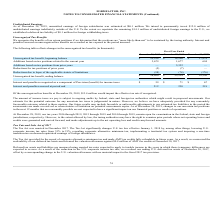According to Formfactor's financial document, What is the unrecognized tax benefit, ending balance in 2019? According to the financial document, $28,800 (in thousands). The relevant text states: "Unrecognized tax benefit, ending balance $ 28,800 $ 25,224 $ 18,296..." Also, What were the Unrecognized tax benefit, beginning balance in 2019, 2018 and 2017 respectively? The document contains multiple relevant values: 25,224, 18,296, 17,978 (in thousands). From the document: "ognized tax benefit, beginning balance $ 25,224 $ 18,296 $ 17,978 Unrecognized tax benefit, beginning balance $ 25,224 $ 18,296 $ 17,978 ax benefit, b..." Also, Which tax years are open for examination in the federal, state and foreign jurisdictions respectively? The document contains multiple relevant values: 2016 through 2019, 2015 through 2019, 2014 through 2019. From the document: "At December 28, 2019, our tax years 2016 through 2019, 2015 through 2019 and 2014 through 2019, remain open for examination in the federal, state and ..." Also, can you calculate: What is the change in the Unrecognized tax benefit, beginning balance from 2018 to 2019? Based on the calculation: 25,224 - 18,296, the result is 6928 (in thousands). This is based on the information: "ognized tax benefit, beginning balance $ 25,224 $ 18,296 $ 17,978 Unrecognized tax benefit, beginning balance $ 25,224 $ 18,296 $ 17,978..." The key data points involved are: 18,296, 25,224. Also, can you calculate: What is the average Additions based on tax positions related to the current year from 2017-2019? To answer this question, I need to perform calculations using the financial data. The calculation is: (3,679 + 1,677 + 694) / 3, which equals 2016.67 (in thousands). This is based on the information: "positions related to the current year 3,679 1,677 694 n tax positions related to the current year 3,679 1,677 694 ased on tax positions related to the current year 3,679 1,677 694..." The key data points involved are: 1,677, 3,679, 694. Additionally, Which year has the highest Unrecognized tax benefit, ending balance? According to the financial document, 2019. The relevant text states: "December 28, 2019 December 29, 2018 December 30, 2017..." 